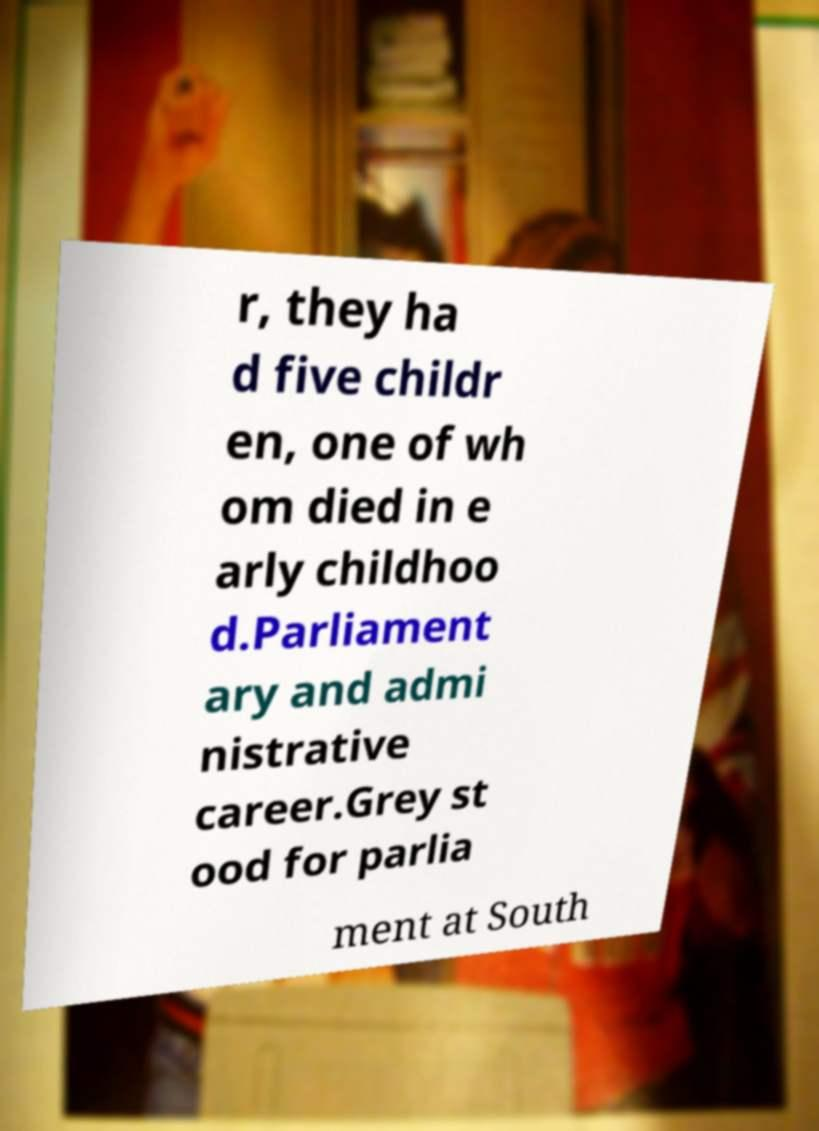There's text embedded in this image that I need extracted. Can you transcribe it verbatim? r, they ha d five childr en, one of wh om died in e arly childhoo d.Parliament ary and admi nistrative career.Grey st ood for parlia ment at South 